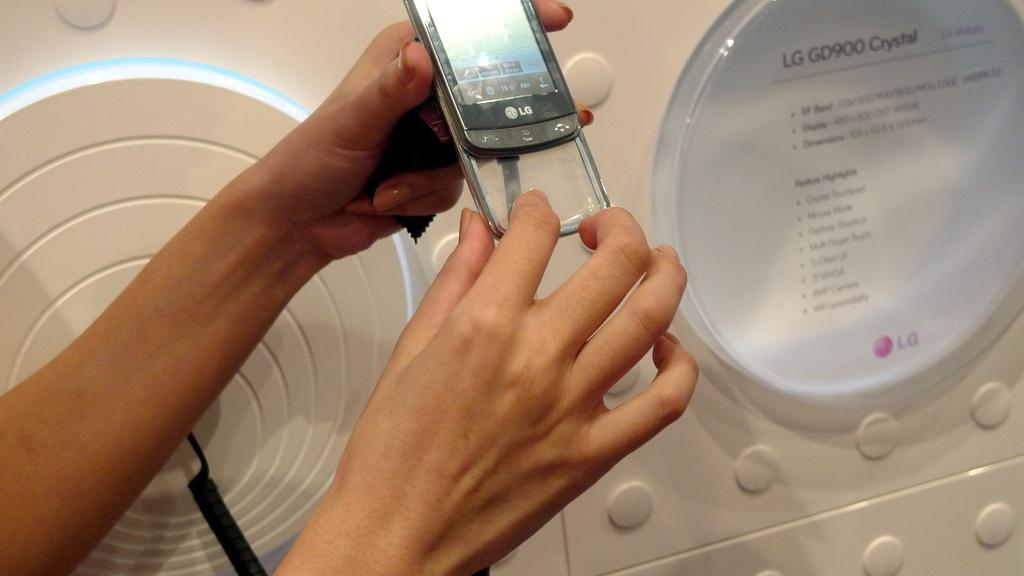<image>
Share a concise interpretation of the image provided. A person demonstrates one of the features of a new LG brand phone. 